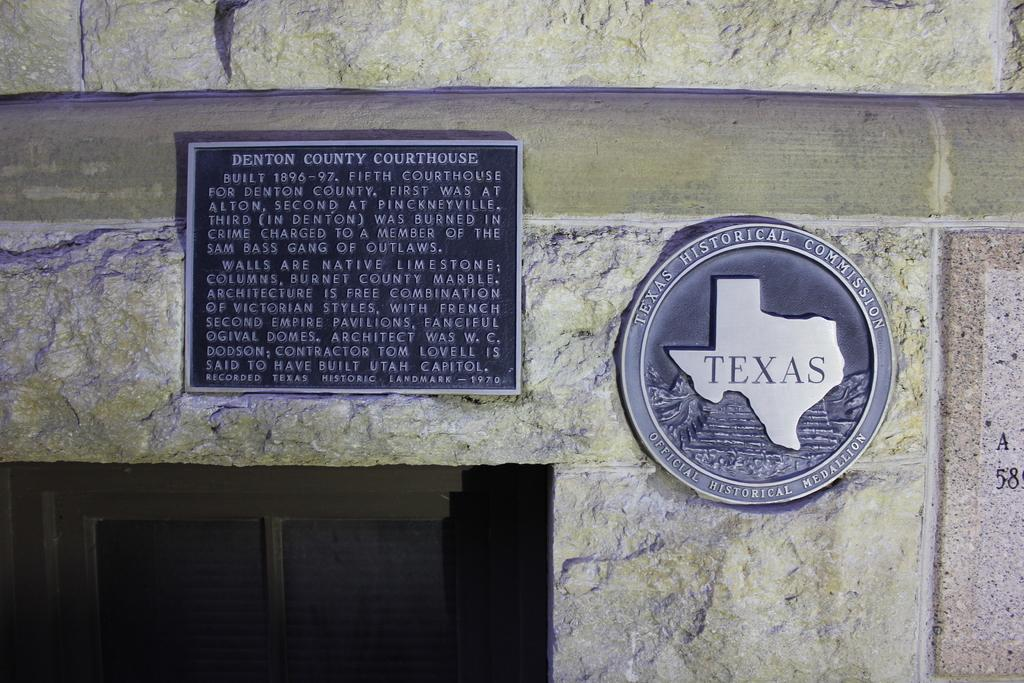What is attached to the wall in the image? There are boards on the wall in the image. Can you describe the wooden object in the image? There is a wooden object between the wall in the image. What type of cakes are being served in the image? There are no cakes present in the image; it only features boards on the wall and a wooden object. What kind of noise can be heard coming from the wooden object in the image? There is no noise coming from the wooden object in the image, as it is a still image and cannot produce sound. 